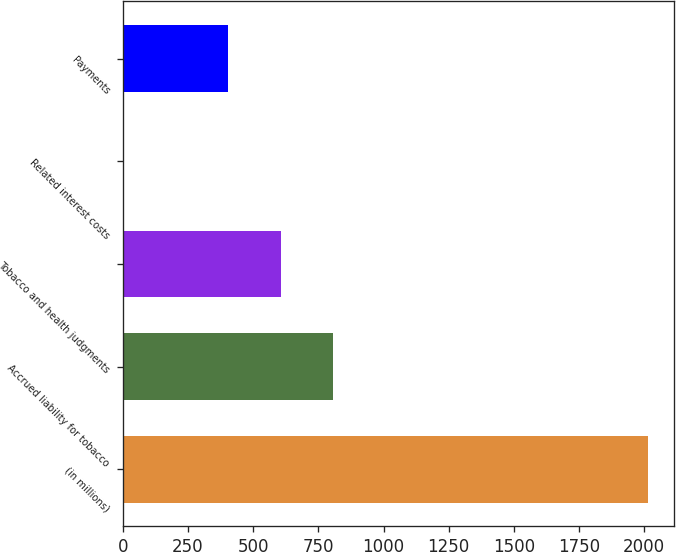Convert chart. <chart><loc_0><loc_0><loc_500><loc_500><bar_chart><fcel>(in millions)<fcel>Accrued liability for tobacco<fcel>Tobacco and health judgments<fcel>Related interest costs<fcel>Payments<nl><fcel>2014<fcel>806.8<fcel>605.6<fcel>2<fcel>404.4<nl></chart> 